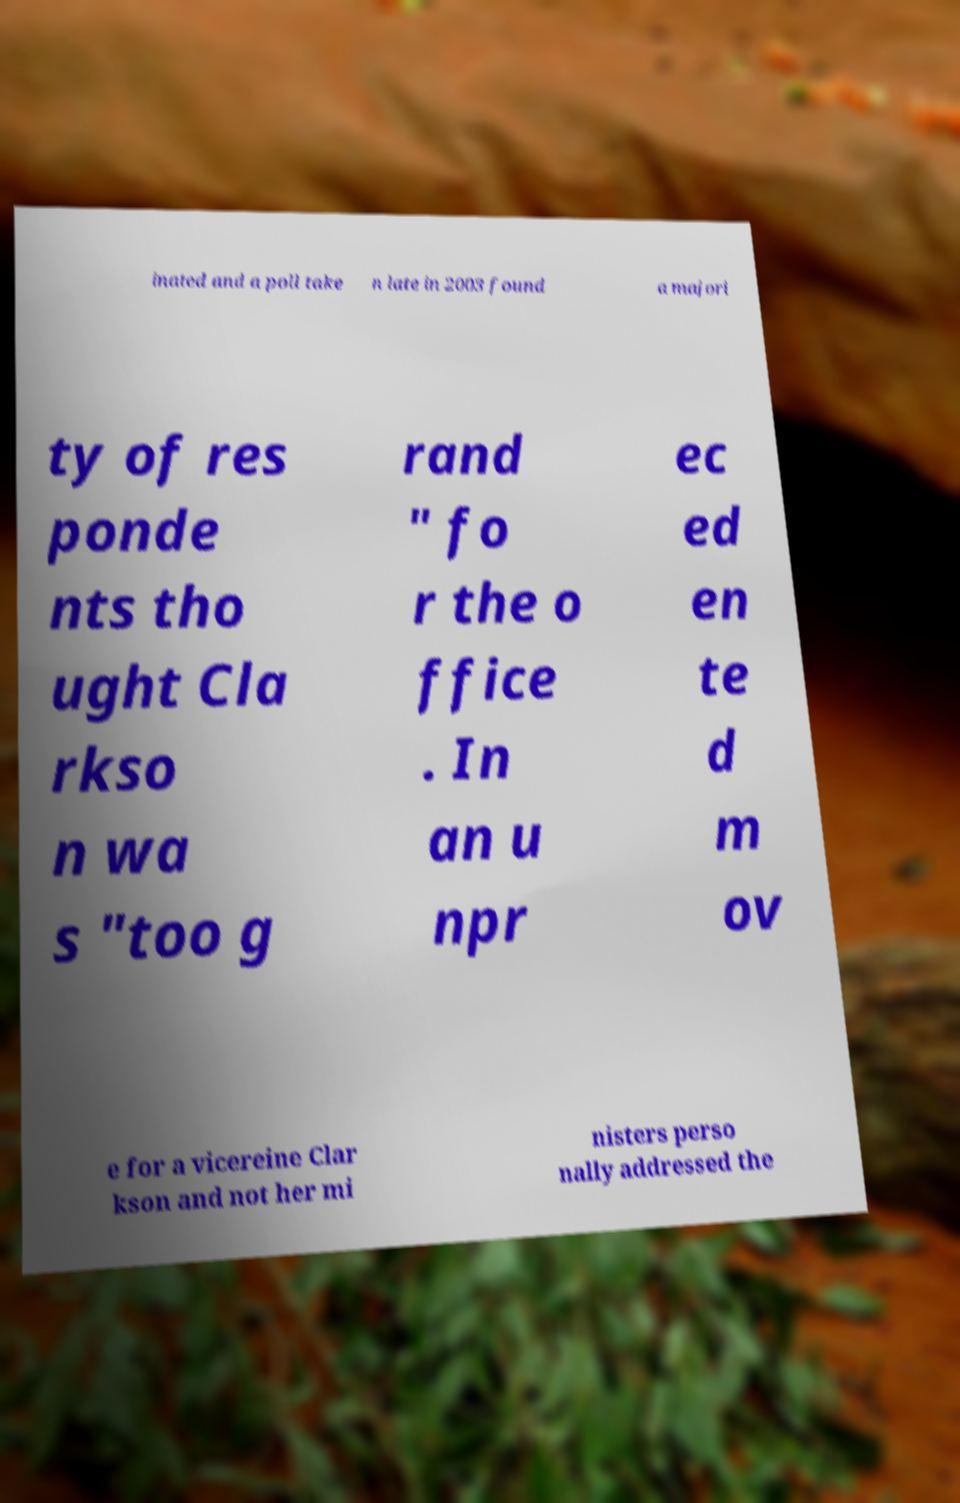For documentation purposes, I need the text within this image transcribed. Could you provide that? inated and a poll take n late in 2003 found a majori ty of res ponde nts tho ught Cla rkso n wa s "too g rand " fo r the o ffice . In an u npr ec ed en te d m ov e for a vicereine Clar kson and not her mi nisters perso nally addressed the 